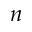<formula> <loc_0><loc_0><loc_500><loc_500>n</formula> 